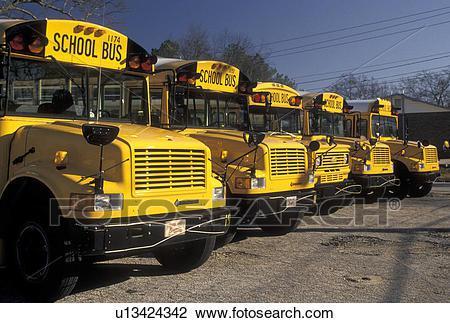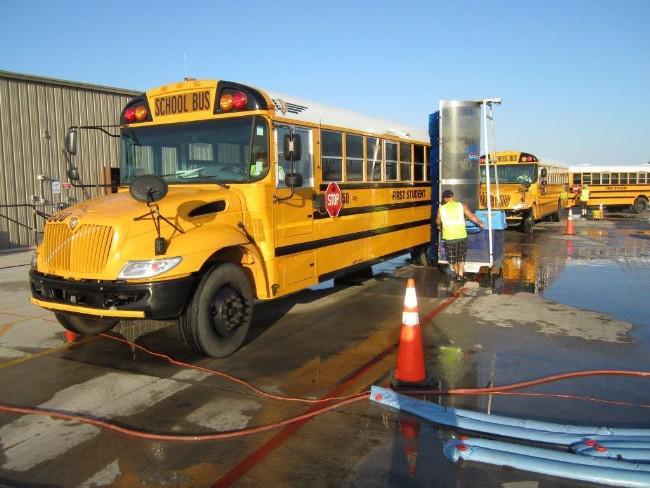The first image is the image on the left, the second image is the image on the right. Considering the images on both sides, is "Some buses have front license plates." valid? Answer yes or no. Yes. The first image is the image on the left, the second image is the image on the right. For the images displayed, is the sentence "At least one image shows buses with forward-turned non-flat fronts parked side-by-side in a row and angled facing rightward." factually correct? Answer yes or no. Yes. 